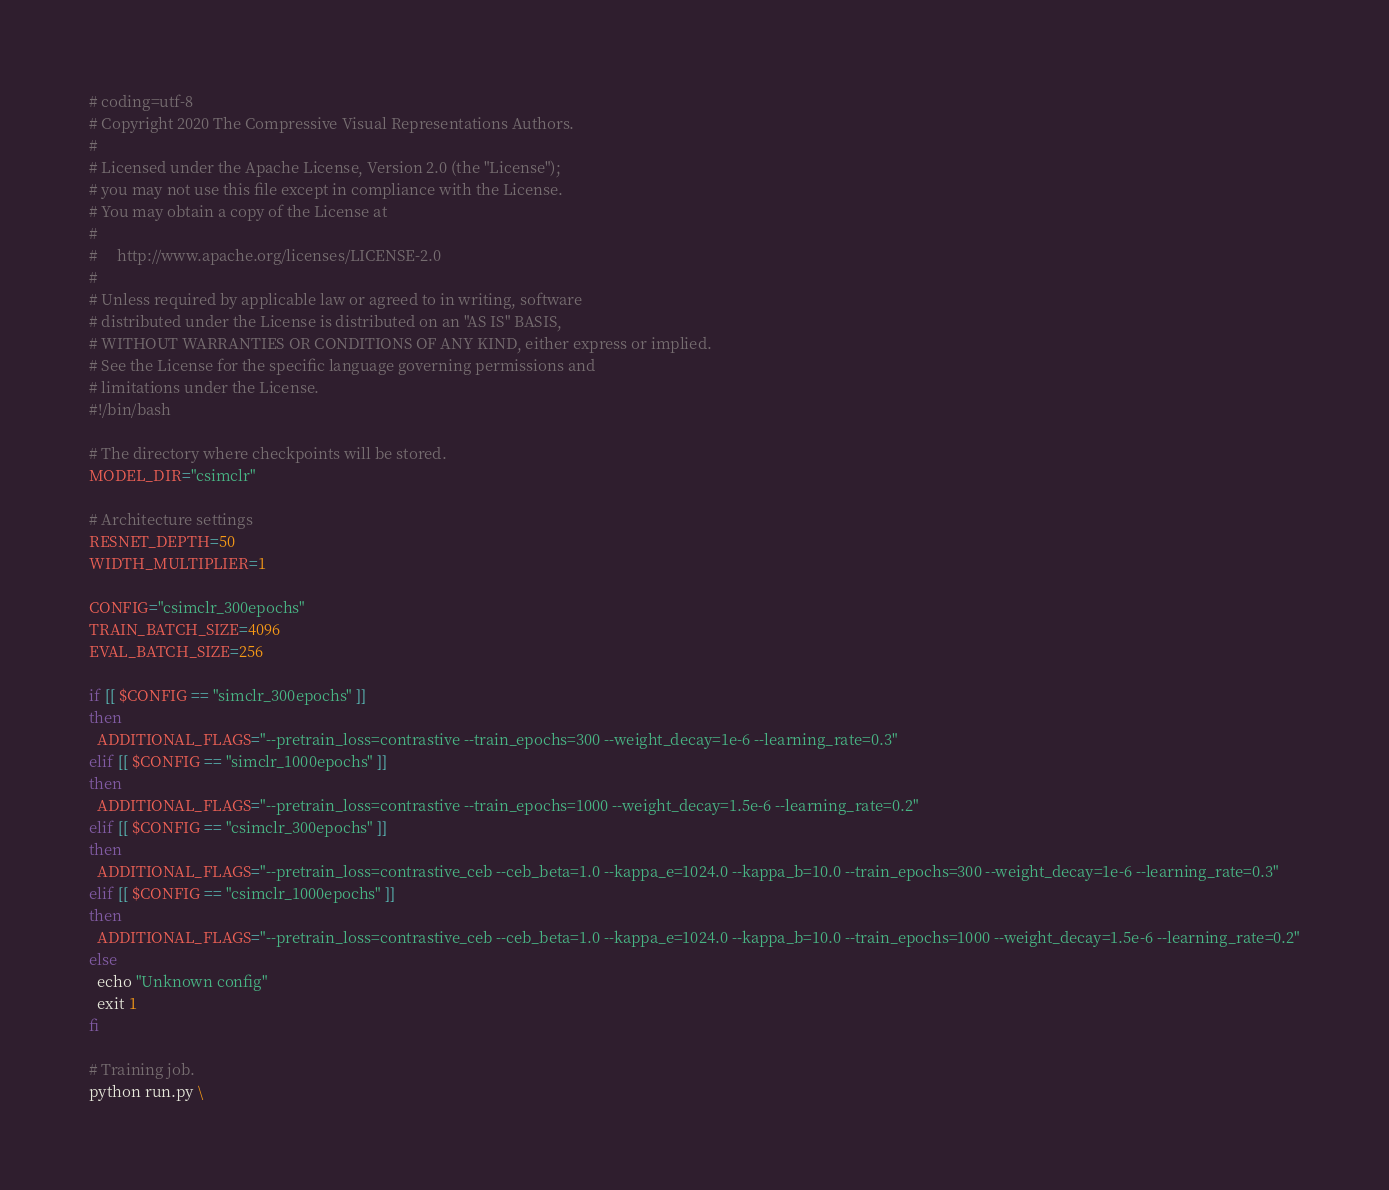<code> <loc_0><loc_0><loc_500><loc_500><_Bash_># coding=utf-8
# Copyright 2020 The Compressive Visual Representations Authors.
#
# Licensed under the Apache License, Version 2.0 (the "License");
# you may not use this file except in compliance with the License.
# You may obtain a copy of the License at
#
#     http://www.apache.org/licenses/LICENSE-2.0
#
# Unless required by applicable law or agreed to in writing, software
# distributed under the License is distributed on an "AS IS" BASIS,
# WITHOUT WARRANTIES OR CONDITIONS OF ANY KIND, either express or implied.
# See the License for the specific language governing permissions and
# limitations under the License.
#!/bin/bash

# The directory where checkpoints will be stored.
MODEL_DIR="csimclr"

# Architecture settings
RESNET_DEPTH=50
WIDTH_MULTIPLIER=1

CONFIG="csimclr_300epochs"
TRAIN_BATCH_SIZE=4096
EVAL_BATCH_SIZE=256

if [[ $CONFIG == "simclr_300epochs" ]]
then
  ADDITIONAL_FLAGS="--pretrain_loss=contrastive --train_epochs=300 --weight_decay=1e-6 --learning_rate=0.3"
elif [[ $CONFIG == "simclr_1000epochs" ]]
then
  ADDITIONAL_FLAGS="--pretrain_loss=contrastive --train_epochs=1000 --weight_decay=1.5e-6 --learning_rate=0.2"
elif [[ $CONFIG == "csimclr_300epochs" ]]
then
  ADDITIONAL_FLAGS="--pretrain_loss=contrastive_ceb --ceb_beta=1.0 --kappa_e=1024.0 --kappa_b=10.0 --train_epochs=300 --weight_decay=1e-6 --learning_rate=0.3"
elif [[ $CONFIG == "csimclr_1000epochs" ]]
then
  ADDITIONAL_FLAGS="--pretrain_loss=contrastive_ceb --ceb_beta=1.0 --kappa_e=1024.0 --kappa_b=10.0 --train_epochs=1000 --weight_decay=1.5e-6 --learning_rate=0.2"
else
  echo "Unknown config"
  exit 1
fi

# Training job.
python run.py \</code> 